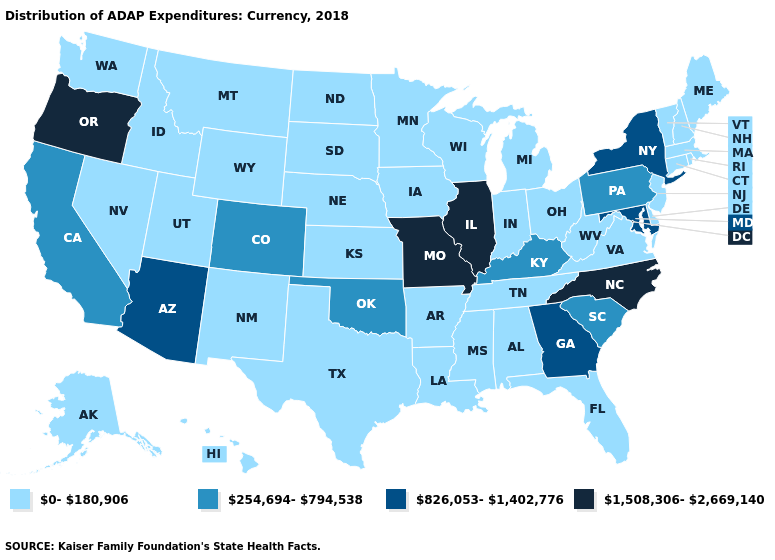Name the states that have a value in the range 0-180,906?
Answer briefly. Alabama, Alaska, Arkansas, Connecticut, Delaware, Florida, Hawaii, Idaho, Indiana, Iowa, Kansas, Louisiana, Maine, Massachusetts, Michigan, Minnesota, Mississippi, Montana, Nebraska, Nevada, New Hampshire, New Jersey, New Mexico, North Dakota, Ohio, Rhode Island, South Dakota, Tennessee, Texas, Utah, Vermont, Virginia, Washington, West Virginia, Wisconsin, Wyoming. What is the highest value in the USA?
Be succinct. 1,508,306-2,669,140. What is the value of Wisconsin?
Write a very short answer. 0-180,906. What is the value of Florida?
Be succinct. 0-180,906. Does Alabama have the same value as Rhode Island?
Quick response, please. Yes. Among the states that border Georgia , does North Carolina have the lowest value?
Give a very brief answer. No. Does Michigan have a lower value than California?
Be succinct. Yes. Name the states that have a value in the range 0-180,906?
Be succinct. Alabama, Alaska, Arkansas, Connecticut, Delaware, Florida, Hawaii, Idaho, Indiana, Iowa, Kansas, Louisiana, Maine, Massachusetts, Michigan, Minnesota, Mississippi, Montana, Nebraska, Nevada, New Hampshire, New Jersey, New Mexico, North Dakota, Ohio, Rhode Island, South Dakota, Tennessee, Texas, Utah, Vermont, Virginia, Washington, West Virginia, Wisconsin, Wyoming. What is the value of Idaho?
Write a very short answer. 0-180,906. Among the states that border Utah , does Arizona have the highest value?
Quick response, please. Yes. What is the highest value in the South ?
Be succinct. 1,508,306-2,669,140. What is the value of Wyoming?
Quick response, please. 0-180,906. Is the legend a continuous bar?
Concise answer only. No. What is the value of Arkansas?
Give a very brief answer. 0-180,906. What is the value of Kansas?
Keep it brief. 0-180,906. 